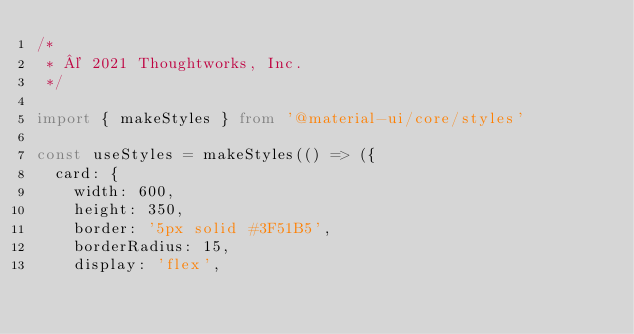<code> <loc_0><loc_0><loc_500><loc_500><_TypeScript_>/*
 * © 2021 Thoughtworks, Inc.
 */

import { makeStyles } from '@material-ui/core/styles'

const useStyles = makeStyles(() => ({
  card: {
    width: 600,
    height: 350,
    border: '5px solid #3F51B5',
    borderRadius: 15,
    display: 'flex',</code> 